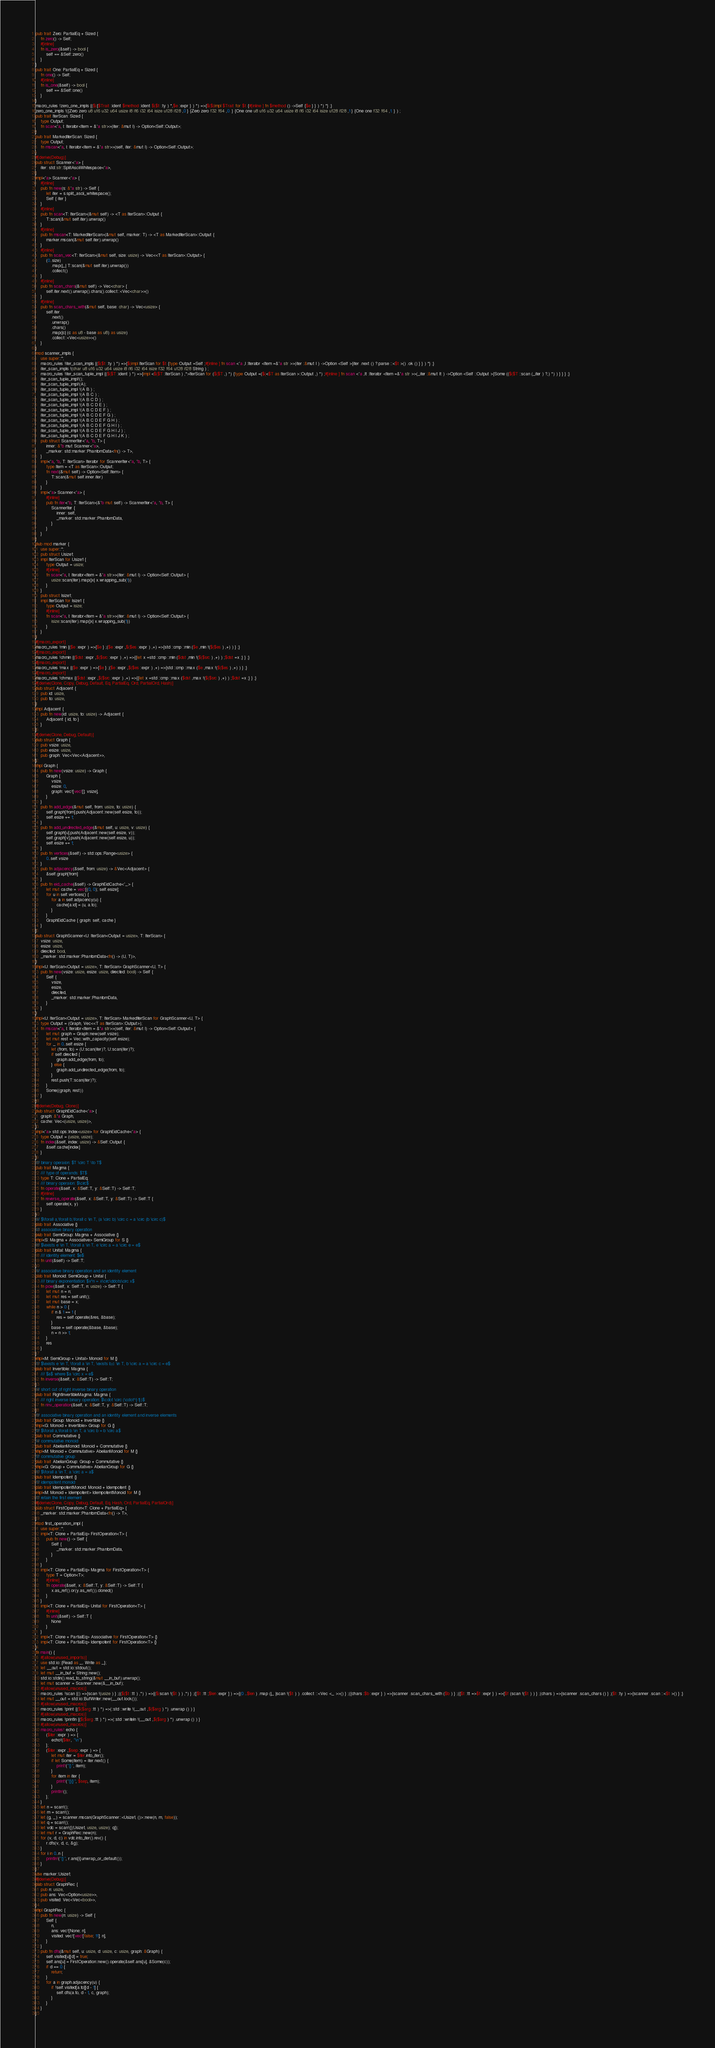Convert code to text. <code><loc_0><loc_0><loc_500><loc_500><_Rust_>pub trait Zero: PartialEq + Sized {
    fn zero() -> Self;
    #[inline]
    fn is_zero(&self) -> bool {
        self == &Self::zero()
    }
}
pub trait One: PartialEq + Sized {
    fn one() -> Self;
    #[inline]
    fn is_one(&self) -> bool {
        self == &Self::one()
    }
}
macro_rules !zero_one_impls {($({$Trait :ident $method :ident $($t :ty ) *,$e :expr } ) *) =>{$($(impl $Trait for $t {#[inline ] fn $method () ->Self {$e } } ) *) *} ;}
zero_one_impls !({Zero zero u8 u16 u32 u64 usize i8 i16 i32 i64 isize u128 i128 ,0 } {Zero zero f32 f64 ,0. } {One one u8 u16 u32 u64 usize i8 i16 i32 i64 isize u128 i128 ,1 } {One one f32 f64 ,1. } ) ;
pub trait IterScan: Sized {
    type Output;
    fn scan<'a, I: Iterator<Item = &'a str>>(iter: &mut I) -> Option<Self::Output>;
}
pub trait MarkedIterScan: Sized {
    type Output;
    fn mscan<'a, I: Iterator<Item = &'a str>>(self, iter: &mut I) -> Option<Self::Output>;
}
#[derive(Debug)]
pub struct Scanner<'a> {
    iter: std::str::SplitAsciiWhitespace<'a>,
}
impl<'a> Scanner<'a> {
    #[inline]
    pub fn new(s: &'a str) -> Self {
        let iter = s.split_ascii_whitespace();
        Self { iter }
    }
    #[inline]
    pub fn scan<T: IterScan>(&mut self) -> <T as IterScan>::Output {
        T::scan(&mut self.iter).unwrap()
    }
    #[inline]
    pub fn mscan<T: MarkedIterScan>(&mut self, marker: T) -> <T as MarkedIterScan>::Output {
        marker.mscan(&mut self.iter).unwrap()
    }
    #[inline]
    pub fn scan_vec<T: IterScan>(&mut self, size: usize) -> Vec<<T as IterScan>::Output> {
        (0..size)
            .map(|_| T::scan(&mut self.iter).unwrap())
            .collect()
    }
    #[inline]
    pub fn scan_chars(&mut self) -> Vec<char> {
        self.iter.next().unwrap().chars().collect::<Vec<char>>()
    }
    #[inline]
    pub fn scan_chars_with(&mut self, base: char) -> Vec<usize> {
        self.iter
            .next()
            .unwrap()
            .chars()
            .map(|c| (c as u8 - base as u8) as usize)
            .collect::<Vec<usize>>()
    }
}
mod scanner_impls {
    use super::*;
    macro_rules !iter_scan_impls {($($t :ty ) *) =>{$(impl IterScan for $t {type Output =Self ;#[inline ] fn scan <'a ,I :Iterator <Item =&'a str >>(iter :&mut I ) ->Option <Self >{iter .next () ?.parse ::<$t >() .ok () } } ) *} ;}
    iter_scan_impls !(char u8 u16 u32 u64 usize i8 i16 i32 i64 isize f32 f64 u128 i128 String ) ;
    macro_rules !iter_scan_tuple_impl {($($T :ident ) *) =>{impl <$($T :IterScan ) ,*>IterScan for ($($T ,) *) {type Output =($(<$T as IterScan >::Output ,) *) ;#[inline ] fn scan <'a ,It :Iterator <Item =&'a str >>(_iter :&mut It ) ->Option <Self ::Output >{Some (($($T ::scan (_iter ) ?,) *) ) } } } ;}
    iter_scan_tuple_impl!();
    iter_scan_tuple_impl!(A);
    iter_scan_tuple_impl !(A B ) ;
    iter_scan_tuple_impl !(A B C ) ;
    iter_scan_tuple_impl !(A B C D ) ;
    iter_scan_tuple_impl !(A B C D E ) ;
    iter_scan_tuple_impl !(A B C D E F ) ;
    iter_scan_tuple_impl !(A B C D E F G ) ;
    iter_scan_tuple_impl !(A B C D E F G H ) ;
    iter_scan_tuple_impl !(A B C D E F G H I ) ;
    iter_scan_tuple_impl !(A B C D E F G H I J ) ;
    iter_scan_tuple_impl !(A B C D E F G H I J K ) ;
    pub struct ScannerIter<'a, 'b, T> {
        inner: &'b mut Scanner<'a>,
        _marker: std::marker::PhantomData<fn() -> T>,
    }
    impl<'a, 'b, T: IterScan> Iterator for ScannerIter<'a, 'b, T> {
        type Item = <T as IterScan>::Output;
        fn next(&mut self) -> Option<Self::Item> {
            T::scan(&mut self.inner.iter)
        }
    }
    impl<'a> Scanner<'a> {
        #[inline]
        pub fn iter<'b, T: IterScan>(&'b mut self) -> ScannerIter<'a, 'b, T> {
            ScannerIter {
                inner: self,
                _marker: std::marker::PhantomData,
            }
        }
    }
}
pub mod marker {
    use super::*;
    pub struct Usize1;
    impl IterScan for Usize1 {
        type Output = usize;
        #[inline]
        fn scan<'a, I: Iterator<Item = &'a str>>(iter: &mut I) -> Option<Self::Output> {
            usize::scan(iter).map(|x| x.wrapping_sub(1))
        }
    }
    pub struct Isize1;
    impl IterScan for Isize1 {
        type Output = isize;
        #[inline]
        fn scan<'a, I: Iterator<Item = &'a str>>(iter: &mut I) -> Option<Self::Output> {
            isize::scan(iter).map(|x| x.wrapping_sub(1))
        }
    }
}
#[macro_export]
macro_rules !min {($e :expr ) =>{$e } ;($e :expr ,$($es :expr ) ,+) =>{std ::cmp ::min ($e ,min !($($es ) ,+) ) } ;}
#[macro_export]
macro_rules !chmin {($dst :expr ,$($src :expr ) ,+) =>{{let x =std ::cmp ::min ($dst ,min !($($src ) ,+) ) ;$dst =x ;} } ;}
#[macro_export]
macro_rules !max {($e :expr ) =>{$e } ;($e :expr ,$($es :expr ) ,+) =>{std ::cmp ::max ($e ,max !($($es ) ,+) ) } ;}
#[macro_export]
macro_rules !chmax {($dst :expr ,$($src :expr ) ,+) =>{{let x =std ::cmp ::max ($dst ,max !($($src ) ,+) ) ;$dst =x ;} } ;}
#[derive(Clone, Copy, Debug, Default, Eq, PartialEq, Ord, PartialOrd, Hash)]
pub struct Adjacent {
    pub id: usize,
    pub to: usize,
}
impl Adjacent {
    pub fn new(id: usize, to: usize) -> Adjacent {
        Adjacent { id, to }
    }
}
#[derive(Clone, Debug, Default)]
pub struct Graph {
    pub vsize: usize,
    pub esize: usize,
    pub graph: Vec<Vec<Adjacent>>,
}
impl Graph {
    pub fn new(vsize: usize) -> Graph {
        Graph {
            vsize,
            esize: 0,
            graph: vec![vec![]; vsize],
        }
    }
    pub fn add_edge(&mut self, from: usize, to: usize) {
        self.graph[from].push(Adjacent::new(self.esize, to));
        self.esize += 1;
    }
    pub fn add_undirected_edge(&mut self, u: usize, v: usize) {
        self.graph[u].push(Adjacent::new(self.esize, v));
        self.graph[v].push(Adjacent::new(self.esize, u));
        self.esize += 1;
    }
    pub fn vertices(&self) -> std::ops::Range<usize> {
        0..self.vsize
    }
    pub fn adjacency(&self, from: usize) -> &Vec<Adjacent> {
        &self.graph[from]
    }
    pub fn eid_cache(&self) -> GraphEidCache<'_> {
        let mut cache = vec![(0, 0); self.esize];
        for u in self.vertices() {
            for a in self.adjacency(u) {
                cache[a.id] = (u, a.to);
            }
        }
        GraphEidCache { graph: self, cache }
    }
}
pub struct GraphScanner<U: IterScan<Output = usize>, T: IterScan> {
    vsize: usize,
    esize: usize,
    directed: bool,
    _marker: std::marker::PhantomData<fn() -> (U, T)>,
}
impl<U: IterScan<Output = usize>, T: IterScan> GraphScanner<U, T> {
    pub fn new(vsize: usize, esize: usize, directed: bool) -> Self {
        Self {
            vsize,
            esize,
            directed,
            _marker: std::marker::PhantomData,
        }
    }
}
impl<U: IterScan<Output = usize>, T: IterScan> MarkedIterScan for GraphScanner<U, T> {
    type Output = (Graph, Vec<<T as IterScan>::Output>);
    fn mscan<'a, I: Iterator<Item = &'a str>>(self, iter: &mut I) -> Option<Self::Output> {
        let mut graph = Graph::new(self.vsize);
        let mut rest = Vec::with_capacity(self.esize);
        for _ in 0..self.esize {
            let (from, to) = (U::scan(iter)?, U::scan(iter)?);
            if self.directed {
                graph.add_edge(from, to);
            } else {
                graph.add_undirected_edge(from, to);
            }
            rest.push(T::scan(iter)?);
        }
        Some((graph, rest))
    }
}
#[derive(Debug, Clone)]
pub struct GraphEidCache<'a> {
    graph: &'a Graph,
    cache: Vec<(usize, usize)>,
}
impl<'a> std::ops::Index<usize> for GraphEidCache<'a> {
    type Output = (usize, usize);
    fn index(&self, index: usize) -> &Self::Output {
        &self.cache[index]
    }
}
/// binary operaion: $T \circ T \to T$
pub trait Magma {
    /// type of operands: $T$
    type T: Clone + PartialEq;
    /// binary operaion: $\circ$
    fn operate(&self, x: &Self::T, y: &Self::T) -> Self::T;
    #[inline]
    fn reverse_operate(&self, x: &Self::T, y: &Self::T) -> Self::T {
        self.operate(x, y)
    }
}
/// $\forall a,\forall b,\forall c \in T, (a \circ b) \circ c = a \circ (b \circ c)$
pub trait Associative {}
/// associative binary operation
pub trait SemiGroup: Magma + Associative {}
impl<S: Magma + Associative> SemiGroup for S {}
/// $\exists e \in T, \forall a \in T, e \circ a = a \circ e = e$
pub trait Unital: Magma {
    /// identity element: $e$
    fn unit(&self) -> Self::T;
}
/// associative binary operation and an identity element
pub trait Monoid: SemiGroup + Unital {
    /// binary exponentiation: $x^n = x\circ\ddots\circ x$
    fn pow(&self, x: Self::T, n: usize) -> Self::T {
        let mut n = n;
        let mut res = self.unit();
        let mut base = x;
        while n > 0 {
            if n & 1 == 1 {
                res = self.operate(&res, &base);
            }
            base = self.operate(&base, &base);
            n = n >> 1;
        }
        res
    }
}
impl<M: SemiGroup + Unital> Monoid for M {}
/// $\exists e \in T, \forall a \in T, \exists b,c \in T, b \circ a = a \circ c = e$
pub trait Invertible: Magma {
    /// $a$ where $a \circ x = e$
    fn inverse(&self, x: &Self::T) -> Self::T;
}
/// short cut of right inverse binary operation
pub trait RightInvertibleMagma: Magma {
    /// right inverse binary operation: $\cdot \circ (\cdot^{-1})$
    fn rinv_operation(&self, x: &Self::T, y: &Self::T) -> Self::T;
}
/// associative binary operation and an identity element and inverse elements
pub trait Group: Monoid + Invertible {}
impl<G: Monoid + Invertible> Group for G {}
/// $\forall a,\forall b \in T, a \circ b = b \circ a$
pub trait Commutative {}
/// commutative monoid
pub trait AbelianMonoid: Monoid + Commutative {}
impl<M: Monoid + Commutative> AbelianMonoid for M {}
/// commutative group
pub trait AbelianGroup: Group + Commutative {}
impl<G: Group + Commutative> AbelianGroup for G {}
/// $\forall a \in T, a \circ a = a$
pub trait Idempotent {}
/// idempotent monoid
pub trait IdempotentMonoid: Monoid + Idempotent {}
impl<M: Monoid + Idempotent> IdempotentMonoid for M {}
/// retain the first element
#[derive(Clone, Copy, Debug, Default, Eq, Hash, Ord, PartialEq, PartialOrd)]
pub struct FirstOperation<T: Clone + PartialEq> {
    _marker: std::marker::PhantomData<fn() -> T>,
}
mod first_operation_impl {
    use super::*;
    impl<T: Clone + PartialEq> FirstOperation<T> {
        pub fn new() -> Self {
            Self {
                _marker: std::marker::PhantomData,
            }
        }
    }
    impl<T: Clone + PartialEq> Magma for FirstOperation<T> {
        type T = Option<T>;
        #[inline]
        fn operate(&self, x: &Self::T, y: &Self::T) -> Self::T {
            x.as_ref().or(y.as_ref()).cloned()
        }
    }
    impl<T: Clone + PartialEq> Unital for FirstOperation<T> {
        #[inline]
        fn unit(&self) -> Self::T {
            None
        }
    }
    impl<T: Clone + PartialEq> Associative for FirstOperation<T> {}
    impl<T: Clone + PartialEq> Idempotent for FirstOperation<T> {}
}
fn main() {
    #[allow(unused_imports)]
    use std::io::{Read as _, Write as _};
    let __out = std::io::stdout();
    let mut __in_buf = String::new();
    std::io::stdin().read_to_string(&mut __in_buf).unwrap();
    let mut scanner = Scanner::new(&__in_buf);
    #[allow(unused_macros)]
    macro_rules !scan {() =>{scan !(usize ) } ;(($($t :tt ) ,*) ) =>{($(scan !($t ) ) ,*) } ;([$t :tt ;$len :expr ] ) =>{(0 ..$len ) .map (|_ |scan !($t ) ) .collect ::<Vec <_ >>() } ;({chars :$b :expr } ) =>{scanner .scan_chars_with ($b ) } ;({$t :tt =>$f :expr } ) =>{$f (scan !($t ) ) } ;(chars ) =>{scanner .scan_chars () } ;($t :ty ) =>{scanner .scan ::<$t >() } ;}
    let mut __out = std::io::BufWriter::new(__out.lock());
    #[allow(unused_macros)]
    macro_rules !print {($($arg :tt ) *) =>(::std ::write !(__out ,$($arg ) *) .unwrap () ) }
    #[allow(unused_macros)]
    macro_rules !println {($($arg :tt ) *) =>(::std ::writeln !(__out ,$($arg ) *) .unwrap () ) }
    #[allow(unused_macros)]
    macro_rules! echo {
        ($iter :expr ) => {
            echo!($iter, "\n")
        };
        ($iter :expr ,$sep :expr ) => {
            let mut iter = $iter.into_iter();
            if let Some(item) = iter.next() {
                print!("{}", item);
            }
            for item in iter {
                print!("{}{}", $sep, item);
            }
            println!();
        };
    }
    let n = scan!();
    let m = scan!();
    let (g, _) = scanner.mscan(GraphScanner::<Usize1, ()>::new(n, m, false));
    let q = scan!();
    let vdc = scan!([(Usize1, usize, usize); q]);
    let mut r = GraphRec::new(n);
    for (v, d, c) in vdc.into_iter().rev() {
        r.dfs(v, d, c, &g);
    }
    for i in 0..n {
        println!("{}", r.ans[i].unwrap_or_default());
    }
}
use marker::Usize1;
#[derive(Debug)]
pub struct GraphRec {
    pub n: usize,
    pub ans: Vec<Option<usize>>,
    pub visited: Vec<Vec<bool>>,
}
impl GraphRec {
    pub fn new(n: usize) -> Self {
        Self {
            n,
            ans: vec![None; n],
            visited: vec![vec![false; 11]; n],
        }
    }
    pub fn dfs(&mut self, u: usize, d: usize, c: usize, graph: &Graph) {
        self.visited[u][d] = true;
        self.ans[u] = FirstOperation::new().operate(&self.ans[u], &Some(c));
        if d == 0 {
            return;
        }
        for a in graph.adjacency(u) {
            if !self.visited[a.to][d - 1] {
                self.dfs(a.to, d - 1, c, graph);
            }
        }
    }
}</code> 